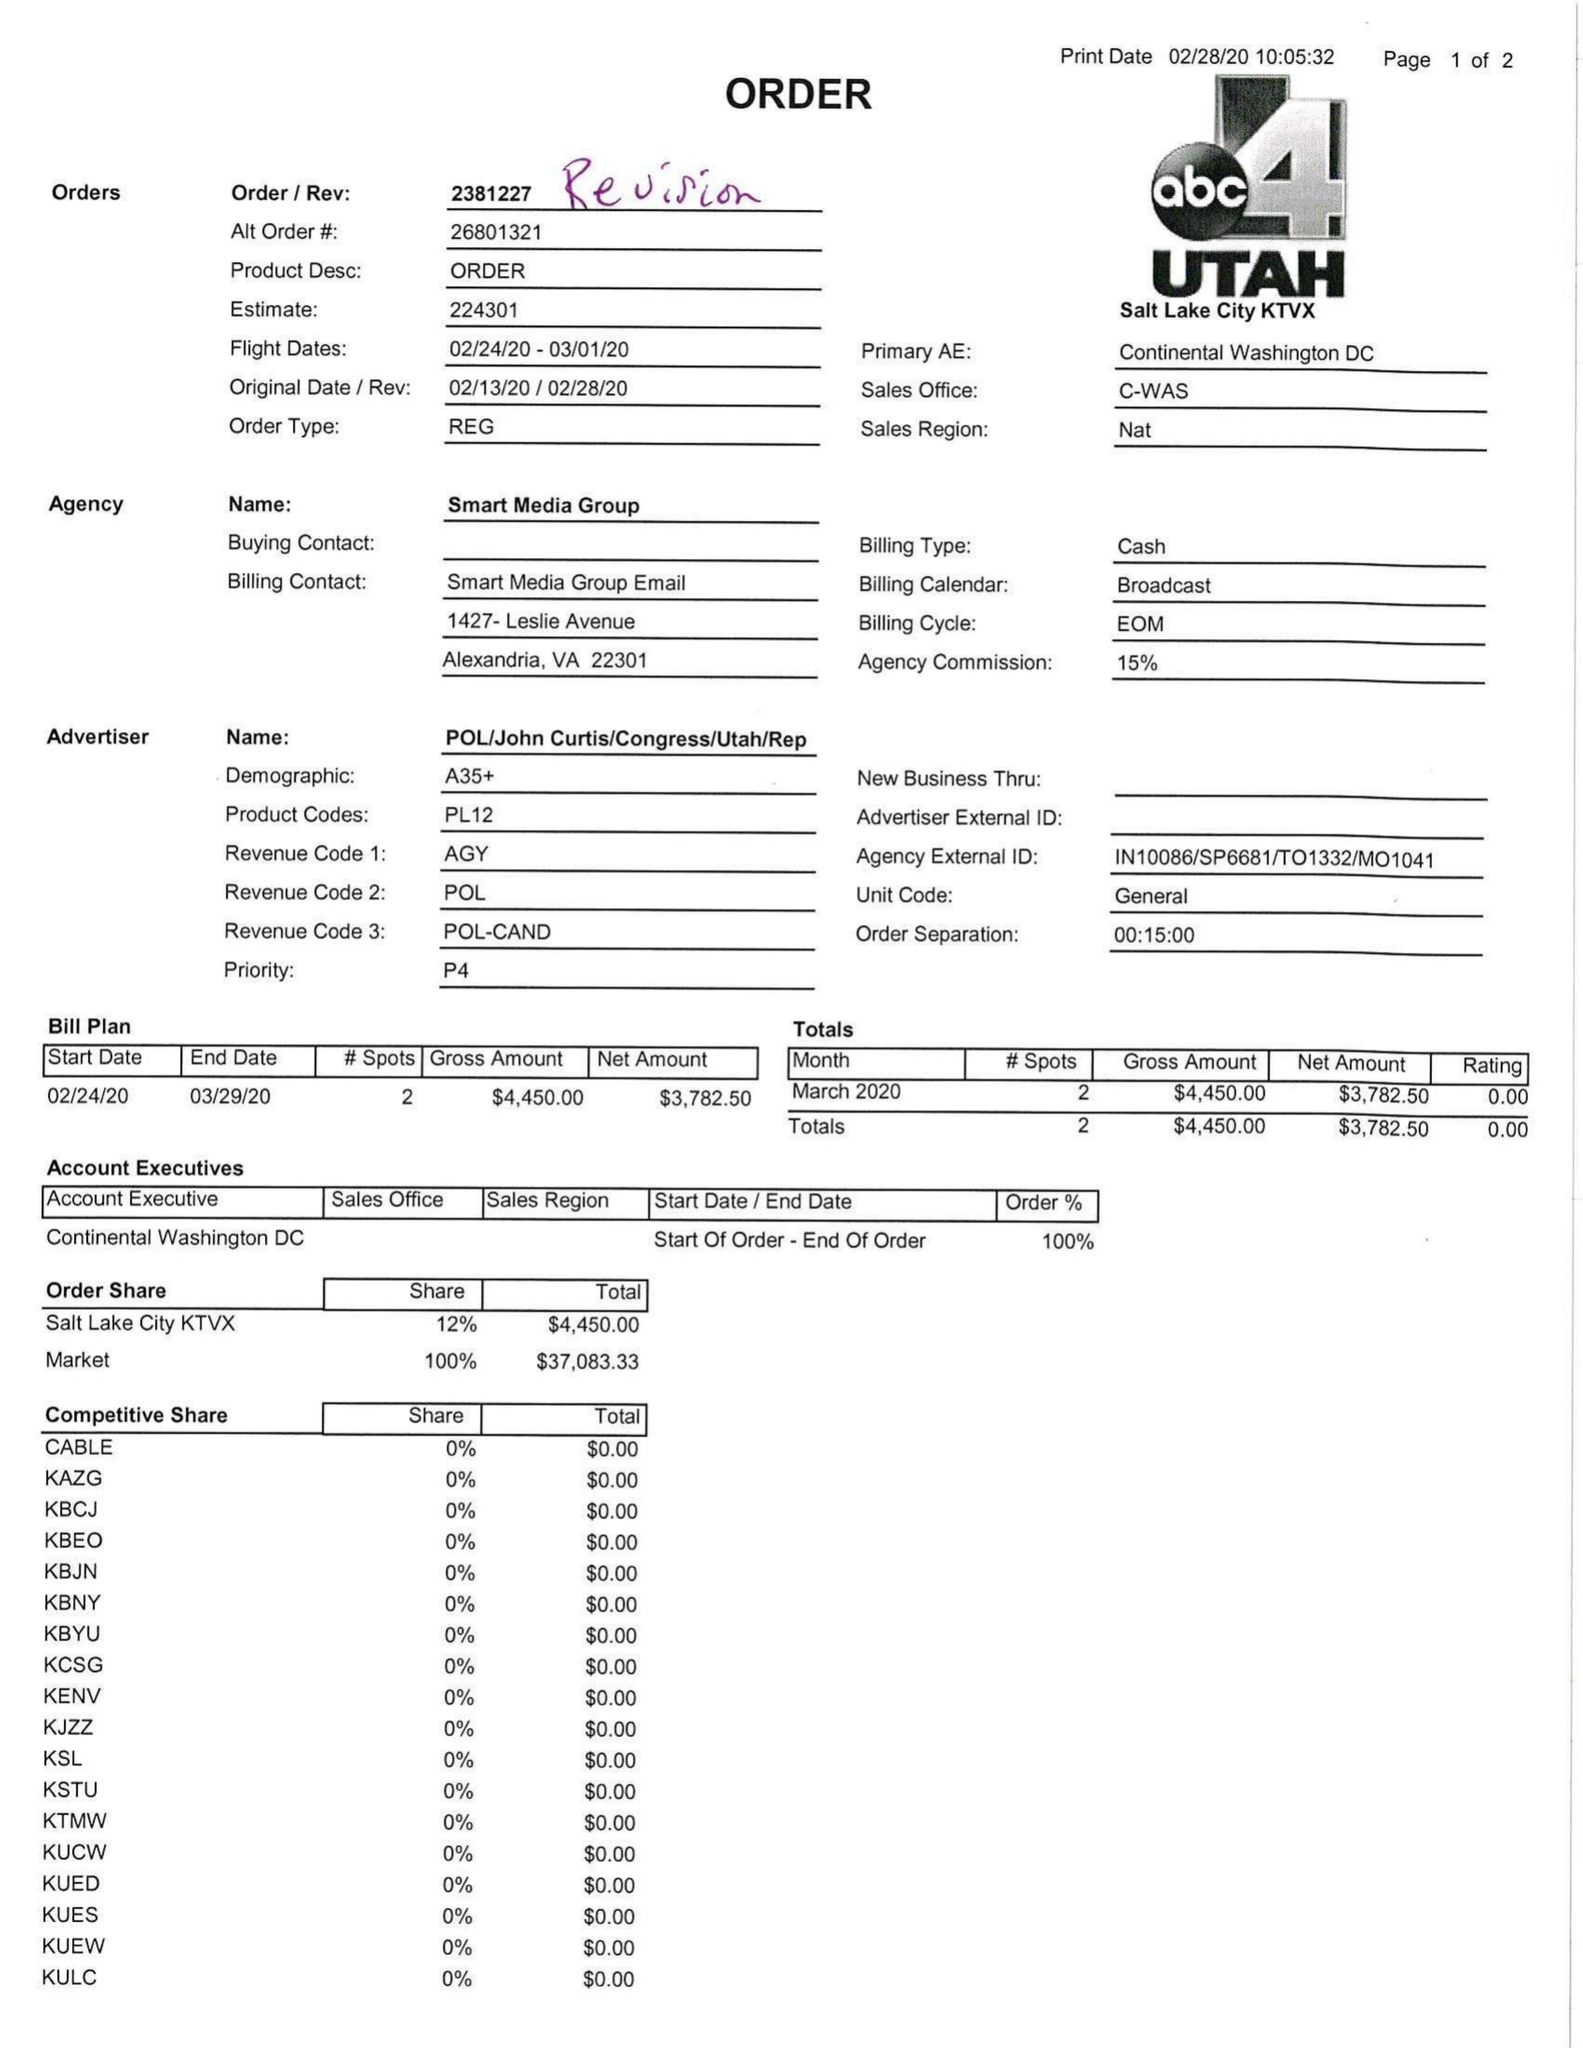What is the value for the contract_num?
Answer the question using a single word or phrase. 2381227 